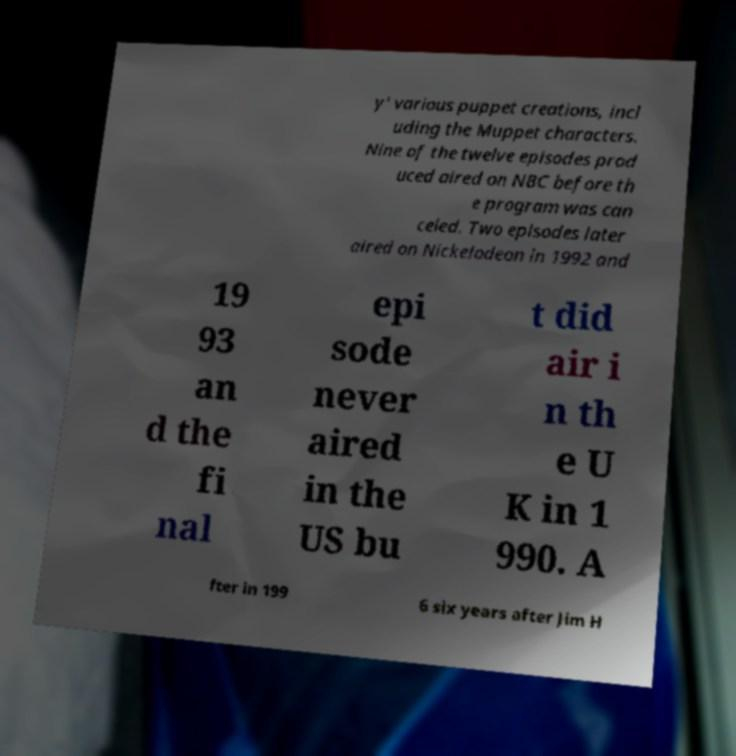Please identify and transcribe the text found in this image. y' various puppet creations, incl uding the Muppet characters. Nine of the twelve episodes prod uced aired on NBC before th e program was can celed. Two episodes later aired on Nickelodeon in 1992 and 19 93 an d the fi nal epi sode never aired in the US bu t did air i n th e U K in 1 990. A fter in 199 6 six years after Jim H 